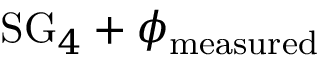<formula> <loc_0><loc_0><loc_500><loc_500>S G _ { 4 } + \phi _ { m e a s u r e d }</formula> 